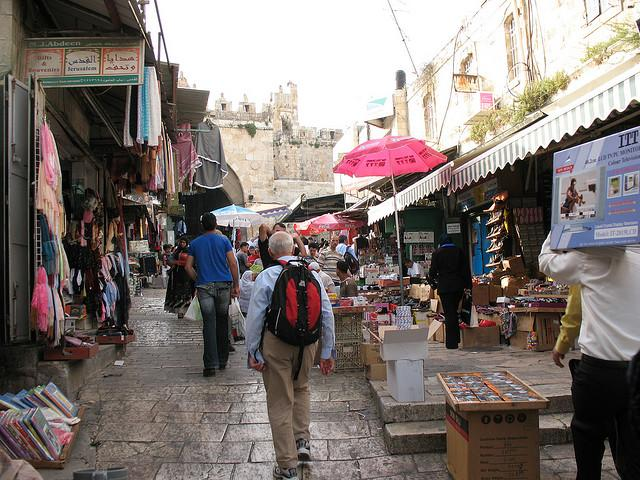What are the people walking through this area looking to do? shop 